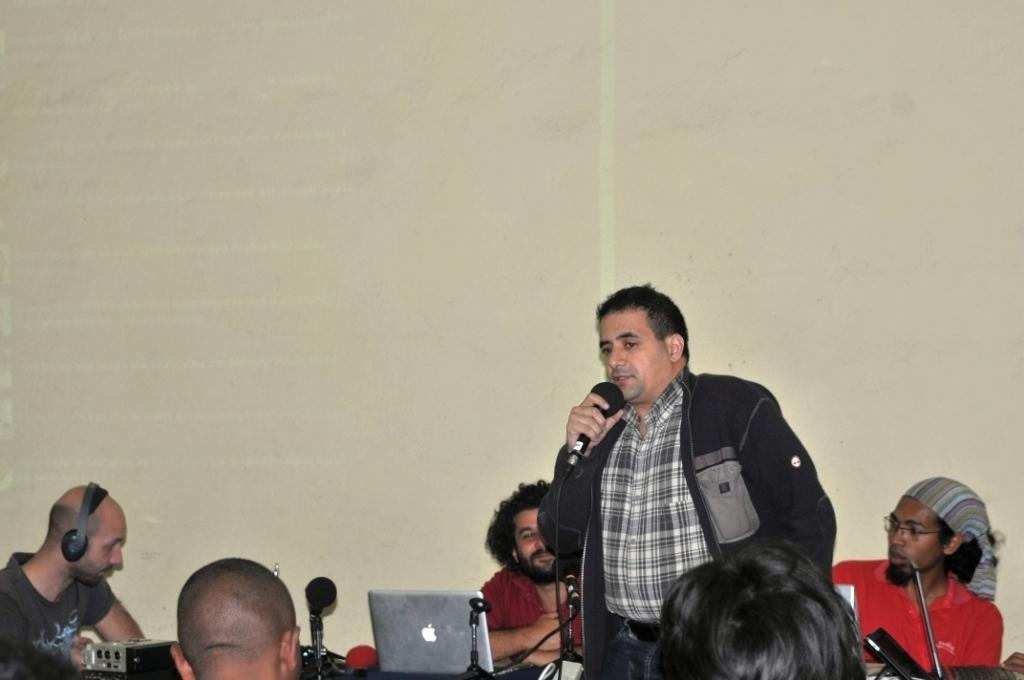How many people are in the image? There are people in the image, but the exact number is not specified. What is one person doing in the image? One person is holding a microphone in the image. What electronic devices can be seen in the image? There are laptops and microphones in the image. What else can be seen in the image besides people and electronic devices? There are other objects in the image, but their specific nature is not mentioned. What is visible in the background of the image? There is a wall visible in the image. What type of jam is being spread on the person's leg in the image? There is no jam or leg present in the image; the facts provided do not mention any such elements. 